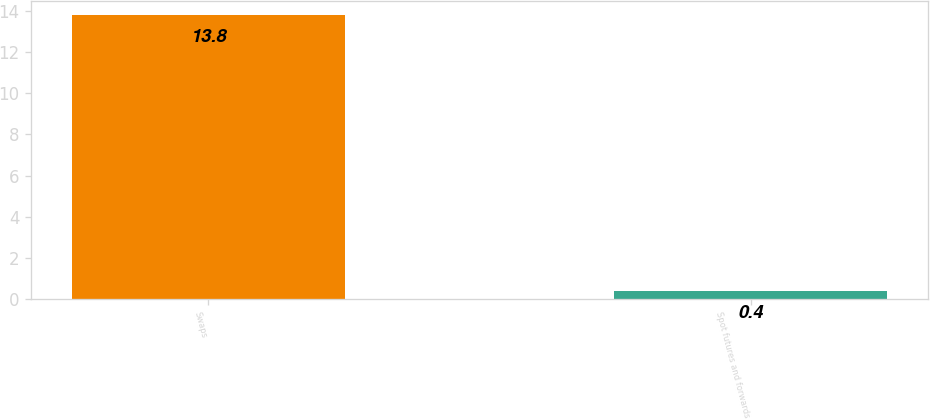<chart> <loc_0><loc_0><loc_500><loc_500><bar_chart><fcel>Swaps<fcel>Spot futures and forwards<nl><fcel>13.8<fcel>0.4<nl></chart> 